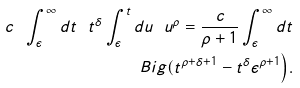Convert formula to latex. <formula><loc_0><loc_0><loc_500><loc_500>c \ \int _ { \epsilon } ^ { \infty } d t \ t ^ { \delta } \int _ { \epsilon } ^ { t } d u \ u ^ { \rho } = \frac { c } { \rho + 1 } \int _ { \epsilon } ^ { \infty } d t \\ B i g ( t ^ { \rho + \delta + 1 } - t ^ { \delta } \epsilon ^ { \rho + 1 } \Big ) .</formula> 